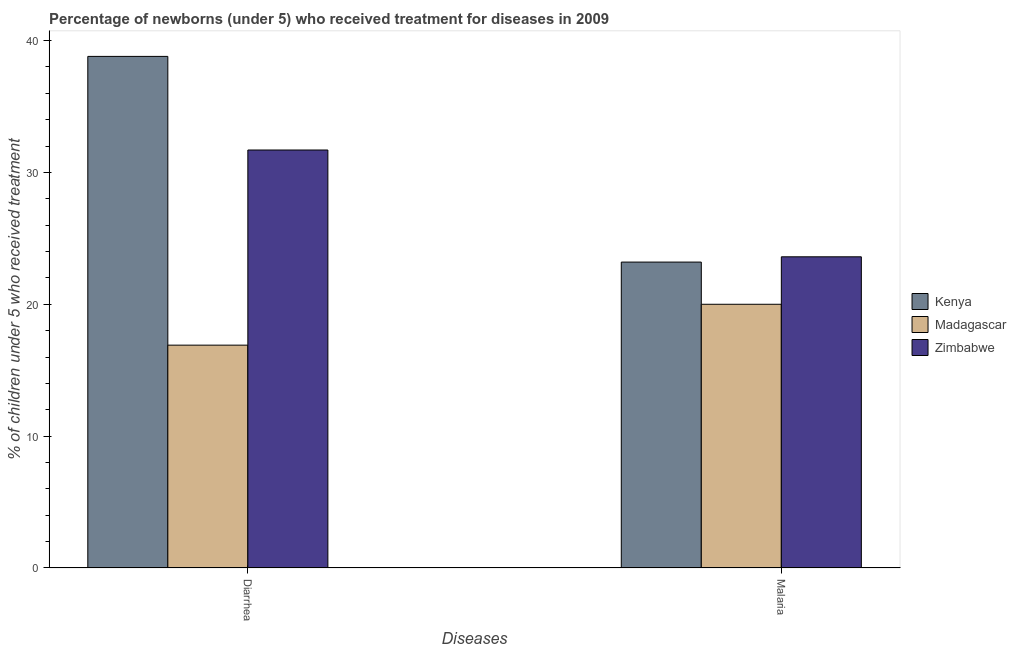How many groups of bars are there?
Provide a succinct answer. 2. What is the label of the 2nd group of bars from the left?
Give a very brief answer. Malaria. What is the percentage of children who received treatment for diarrhoea in Kenya?
Your answer should be compact. 38.8. Across all countries, what is the maximum percentage of children who received treatment for diarrhoea?
Offer a terse response. 38.8. Across all countries, what is the minimum percentage of children who received treatment for diarrhoea?
Give a very brief answer. 16.9. In which country was the percentage of children who received treatment for malaria maximum?
Give a very brief answer. Zimbabwe. In which country was the percentage of children who received treatment for malaria minimum?
Make the answer very short. Madagascar. What is the total percentage of children who received treatment for malaria in the graph?
Your answer should be very brief. 66.8. What is the difference between the percentage of children who received treatment for diarrhoea in Zimbabwe and that in Kenya?
Offer a very short reply. -7.1. What is the difference between the percentage of children who received treatment for malaria in Zimbabwe and the percentage of children who received treatment for diarrhoea in Madagascar?
Offer a very short reply. 6.7. What is the average percentage of children who received treatment for diarrhoea per country?
Your response must be concise. 29.13. What is the difference between the percentage of children who received treatment for diarrhoea and percentage of children who received treatment for malaria in Zimbabwe?
Ensure brevity in your answer.  8.1. What is the ratio of the percentage of children who received treatment for diarrhoea in Madagascar to that in Kenya?
Ensure brevity in your answer.  0.44. Is the percentage of children who received treatment for diarrhoea in Kenya less than that in Zimbabwe?
Your answer should be compact. No. In how many countries, is the percentage of children who received treatment for malaria greater than the average percentage of children who received treatment for malaria taken over all countries?
Your answer should be compact. 2. What does the 1st bar from the left in Diarrhea represents?
Your answer should be very brief. Kenya. What does the 3rd bar from the right in Diarrhea represents?
Give a very brief answer. Kenya. How many bars are there?
Your answer should be very brief. 6. Are the values on the major ticks of Y-axis written in scientific E-notation?
Keep it short and to the point. No. Does the graph contain any zero values?
Ensure brevity in your answer.  No. How many legend labels are there?
Provide a short and direct response. 3. How are the legend labels stacked?
Ensure brevity in your answer.  Vertical. What is the title of the graph?
Give a very brief answer. Percentage of newborns (under 5) who received treatment for diseases in 2009. What is the label or title of the X-axis?
Your answer should be very brief. Diseases. What is the label or title of the Y-axis?
Your answer should be very brief. % of children under 5 who received treatment. What is the % of children under 5 who received treatment in Kenya in Diarrhea?
Offer a very short reply. 38.8. What is the % of children under 5 who received treatment in Zimbabwe in Diarrhea?
Offer a very short reply. 31.7. What is the % of children under 5 who received treatment in Kenya in Malaria?
Your response must be concise. 23.2. What is the % of children under 5 who received treatment of Madagascar in Malaria?
Your response must be concise. 20. What is the % of children under 5 who received treatment in Zimbabwe in Malaria?
Your answer should be compact. 23.6. Across all Diseases, what is the maximum % of children under 5 who received treatment in Kenya?
Make the answer very short. 38.8. Across all Diseases, what is the maximum % of children under 5 who received treatment in Madagascar?
Offer a very short reply. 20. Across all Diseases, what is the maximum % of children under 5 who received treatment of Zimbabwe?
Provide a succinct answer. 31.7. Across all Diseases, what is the minimum % of children under 5 who received treatment of Kenya?
Keep it short and to the point. 23.2. Across all Diseases, what is the minimum % of children under 5 who received treatment of Madagascar?
Your answer should be compact. 16.9. Across all Diseases, what is the minimum % of children under 5 who received treatment of Zimbabwe?
Give a very brief answer. 23.6. What is the total % of children under 5 who received treatment of Kenya in the graph?
Provide a short and direct response. 62. What is the total % of children under 5 who received treatment in Madagascar in the graph?
Make the answer very short. 36.9. What is the total % of children under 5 who received treatment of Zimbabwe in the graph?
Offer a terse response. 55.3. What is the difference between the % of children under 5 who received treatment in Madagascar in Diarrhea and that in Malaria?
Give a very brief answer. -3.1. What is the difference between the % of children under 5 who received treatment of Zimbabwe in Diarrhea and that in Malaria?
Offer a terse response. 8.1. What is the difference between the % of children under 5 who received treatment of Madagascar in Diarrhea and the % of children under 5 who received treatment of Zimbabwe in Malaria?
Your answer should be very brief. -6.7. What is the average % of children under 5 who received treatment in Kenya per Diseases?
Make the answer very short. 31. What is the average % of children under 5 who received treatment in Madagascar per Diseases?
Make the answer very short. 18.45. What is the average % of children under 5 who received treatment in Zimbabwe per Diseases?
Give a very brief answer. 27.65. What is the difference between the % of children under 5 who received treatment in Kenya and % of children under 5 who received treatment in Madagascar in Diarrhea?
Provide a succinct answer. 21.9. What is the difference between the % of children under 5 who received treatment in Madagascar and % of children under 5 who received treatment in Zimbabwe in Diarrhea?
Keep it short and to the point. -14.8. What is the difference between the % of children under 5 who received treatment of Kenya and % of children under 5 who received treatment of Madagascar in Malaria?
Make the answer very short. 3.2. What is the difference between the % of children under 5 who received treatment in Madagascar and % of children under 5 who received treatment in Zimbabwe in Malaria?
Your answer should be compact. -3.6. What is the ratio of the % of children under 5 who received treatment of Kenya in Diarrhea to that in Malaria?
Keep it short and to the point. 1.67. What is the ratio of the % of children under 5 who received treatment in Madagascar in Diarrhea to that in Malaria?
Offer a terse response. 0.84. What is the ratio of the % of children under 5 who received treatment of Zimbabwe in Diarrhea to that in Malaria?
Your response must be concise. 1.34. What is the difference between the highest and the second highest % of children under 5 who received treatment of Kenya?
Give a very brief answer. 15.6. What is the difference between the highest and the second highest % of children under 5 who received treatment of Madagascar?
Your response must be concise. 3.1. What is the difference between the highest and the second highest % of children under 5 who received treatment in Zimbabwe?
Make the answer very short. 8.1. What is the difference between the highest and the lowest % of children under 5 who received treatment in Kenya?
Give a very brief answer. 15.6. What is the difference between the highest and the lowest % of children under 5 who received treatment of Zimbabwe?
Make the answer very short. 8.1. 